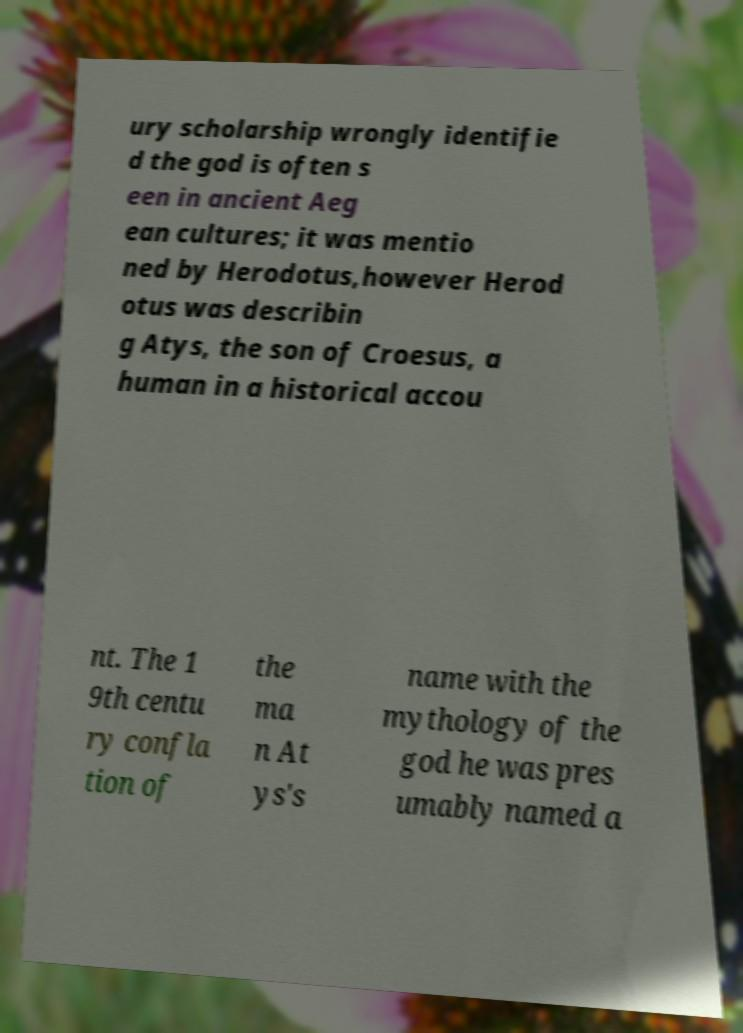Can you read and provide the text displayed in the image?This photo seems to have some interesting text. Can you extract and type it out for me? ury scholarship wrongly identifie d the god is often s een in ancient Aeg ean cultures; it was mentio ned by Herodotus,however Herod otus was describin g Atys, the son of Croesus, a human in a historical accou nt. The 1 9th centu ry confla tion of the ma n At ys's name with the mythology of the god he was pres umably named a 